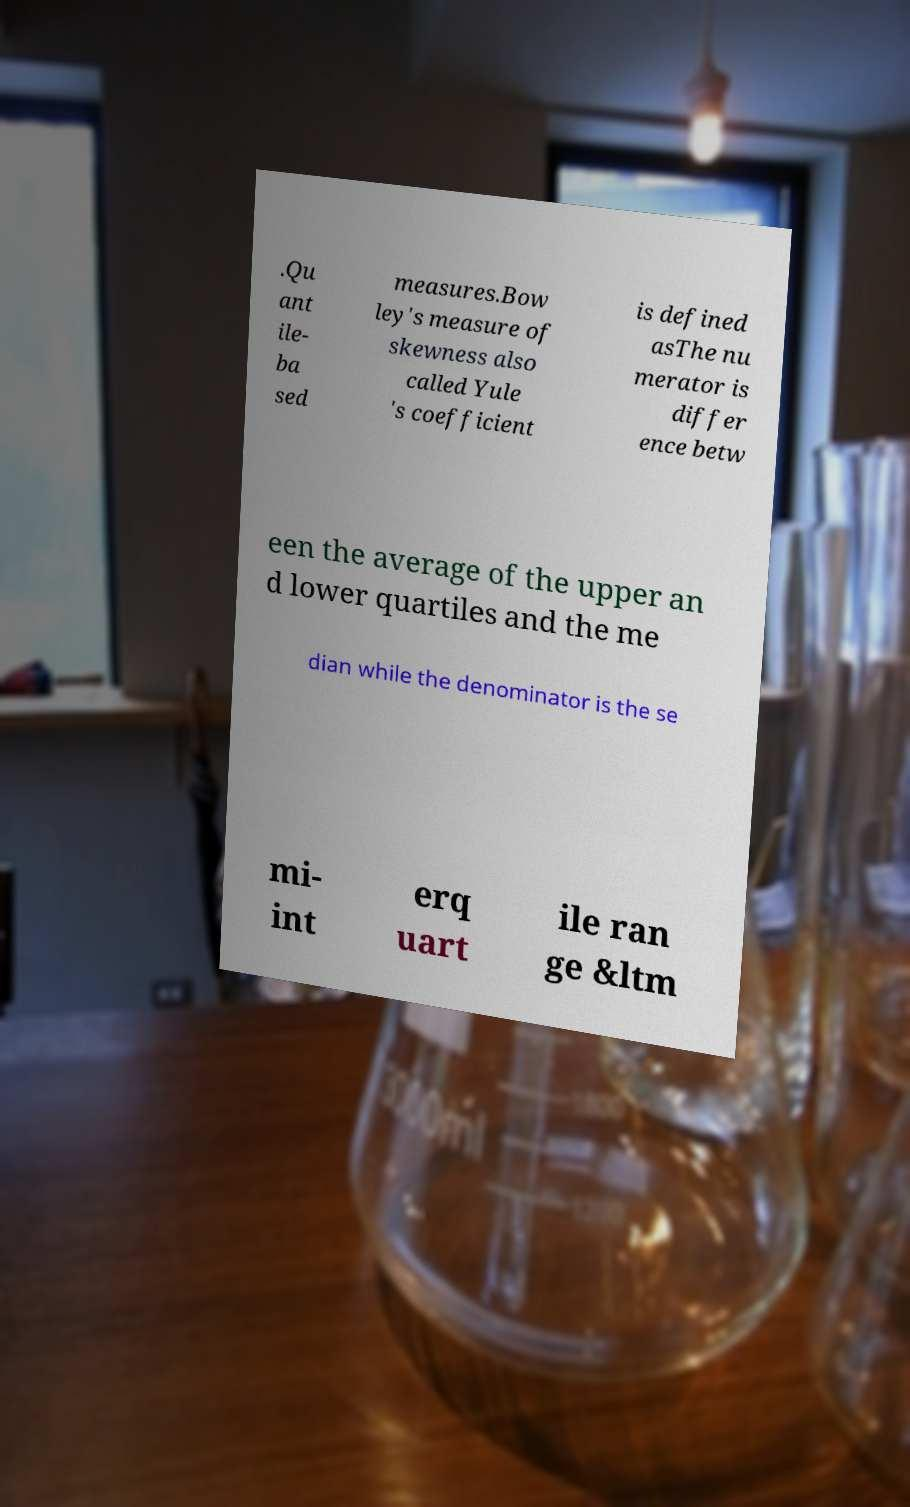Can you accurately transcribe the text from the provided image for me? .Qu ant ile- ba sed measures.Bow ley's measure of skewness also called Yule 's coefficient is defined asThe nu merator is differ ence betw een the average of the upper an d lower quartiles and the me dian while the denominator is the se mi- int erq uart ile ran ge &ltm 